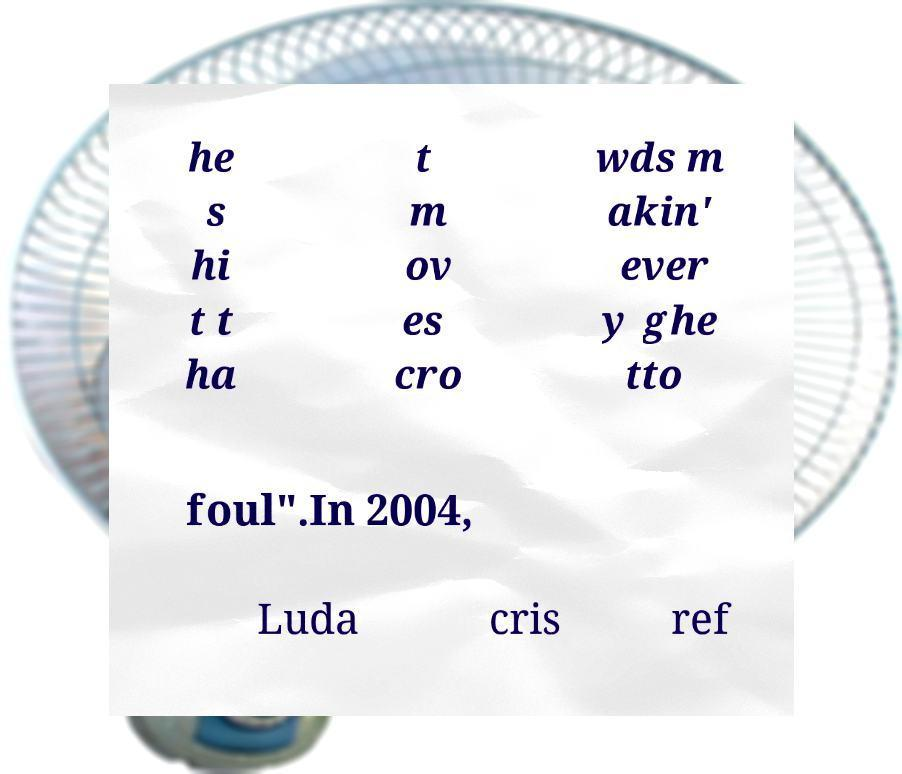Could you assist in decoding the text presented in this image and type it out clearly? he s hi t t ha t m ov es cro wds m akin' ever y ghe tto foul".In 2004, Luda cris ref 